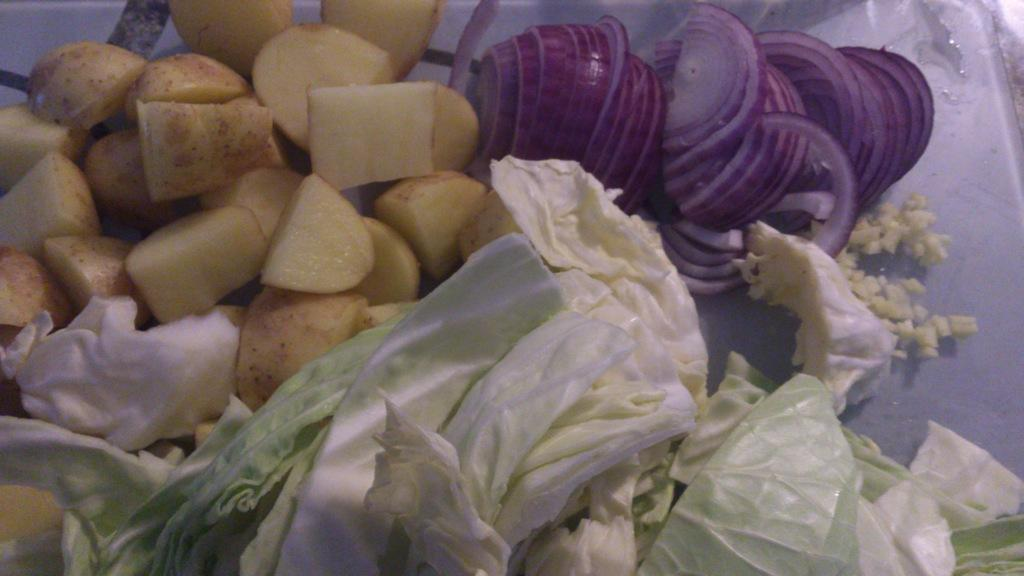What type of vegetables can be seen in the image? There are onions, potatoes, and cabbages in the image. Can you describe the vegetables in more detail? The image shows onions, potatoes, and cabbages. How much money is being exchanged for the vegetables in the image? There is no indication of any money exchange in the image; it only shows onions, potatoes, and cabbages. How many women are present in the image? There are no women present in the image; it only shows onions, potatoes, and cabbages. 